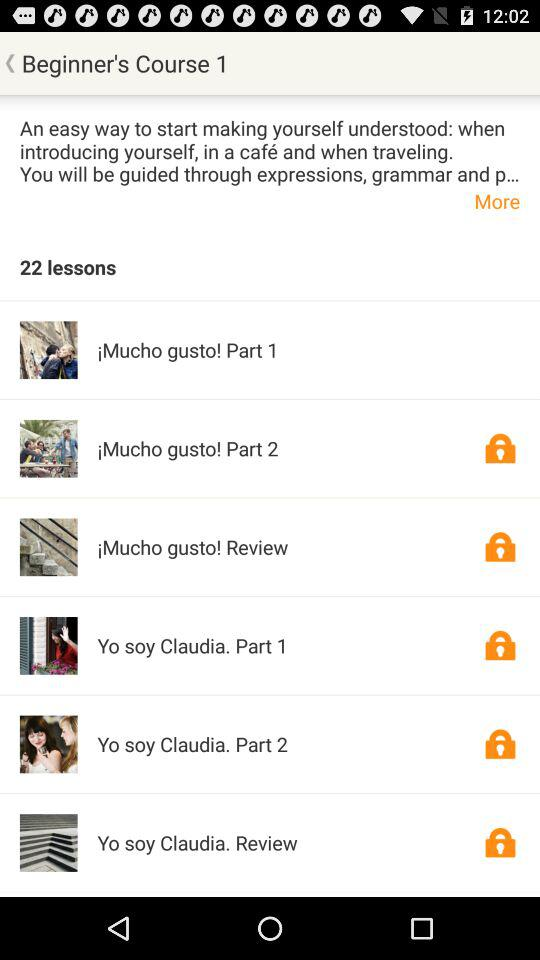What is the level of the course? The level of the course is beginner. 